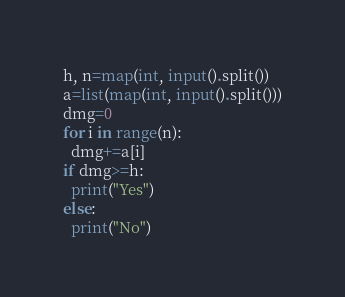Convert code to text. <code><loc_0><loc_0><loc_500><loc_500><_Python_>h, n=map(int, input().split())
a=list(map(int, input().split()))
dmg=0
for i in range(n):
  dmg+=a[i]
if dmg>=h:
  print("Yes")
else:
  print("No")</code> 